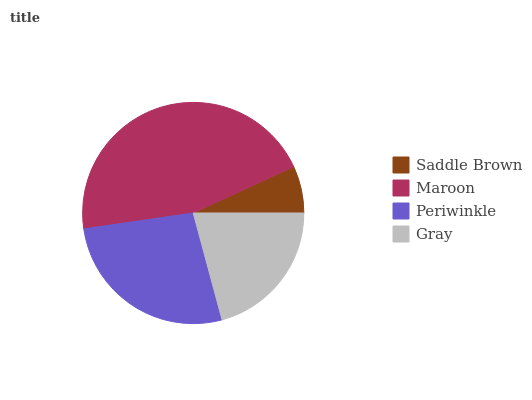Is Saddle Brown the minimum?
Answer yes or no. Yes. Is Maroon the maximum?
Answer yes or no. Yes. Is Periwinkle the minimum?
Answer yes or no. No. Is Periwinkle the maximum?
Answer yes or no. No. Is Maroon greater than Periwinkle?
Answer yes or no. Yes. Is Periwinkle less than Maroon?
Answer yes or no. Yes. Is Periwinkle greater than Maroon?
Answer yes or no. No. Is Maroon less than Periwinkle?
Answer yes or no. No. Is Periwinkle the high median?
Answer yes or no. Yes. Is Gray the low median?
Answer yes or no. Yes. Is Maroon the high median?
Answer yes or no. No. Is Periwinkle the low median?
Answer yes or no. No. 